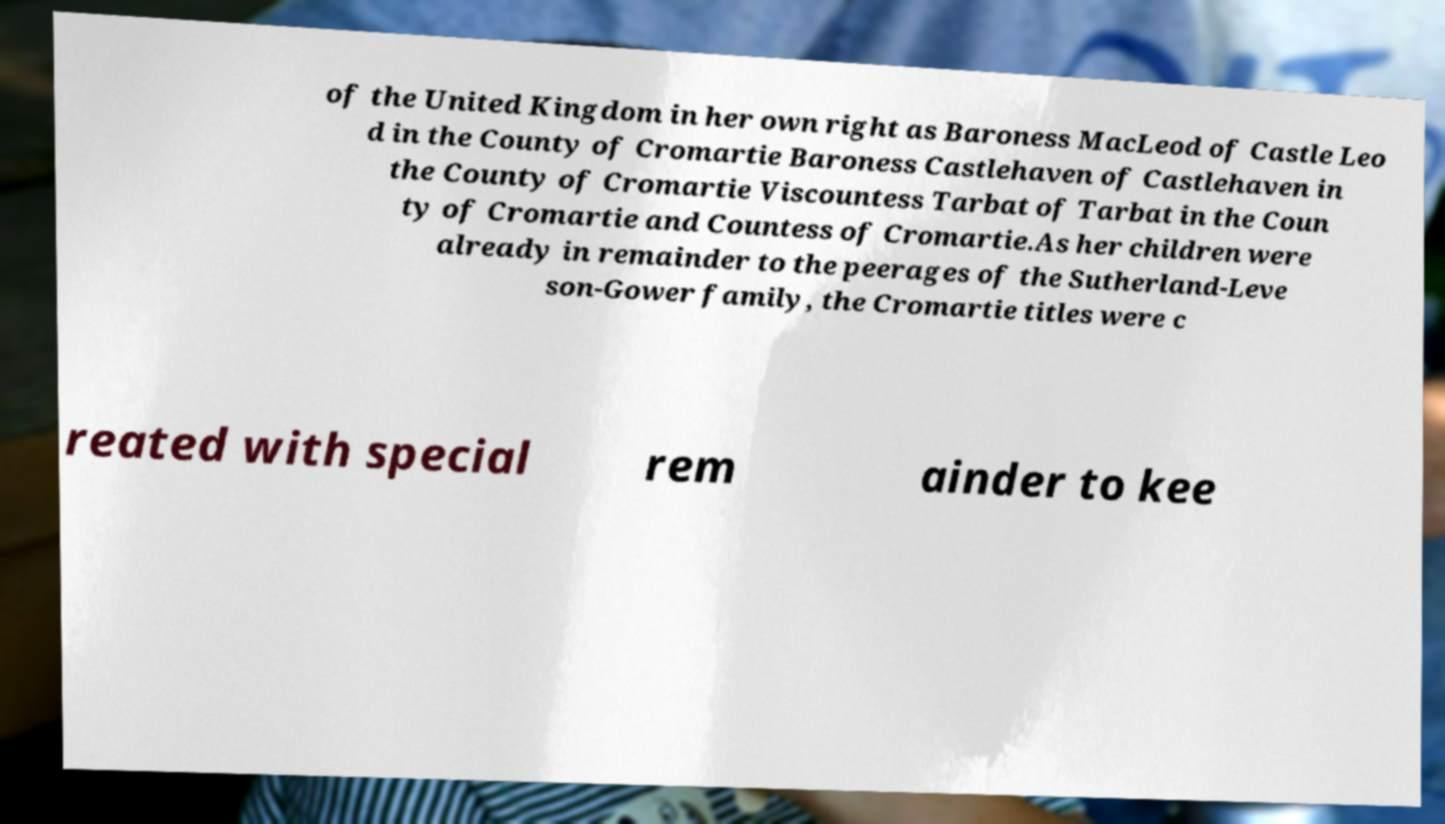Please read and relay the text visible in this image. What does it say? of the United Kingdom in her own right as Baroness MacLeod of Castle Leo d in the County of Cromartie Baroness Castlehaven of Castlehaven in the County of Cromartie Viscountess Tarbat of Tarbat in the Coun ty of Cromartie and Countess of Cromartie.As her children were already in remainder to the peerages of the Sutherland-Leve son-Gower family, the Cromartie titles were c reated with special rem ainder to kee 